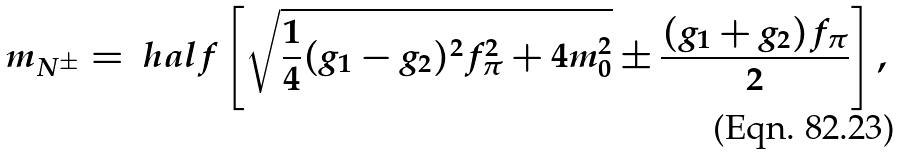Convert formula to latex. <formula><loc_0><loc_0><loc_500><loc_500>m _ { N ^ { \pm } } & = \ h a l f \left [ \sqrt { \frac { 1 } { 4 } ( g _ { 1 } - g _ { 2 } ) ^ { 2 } f _ { \pi } ^ { 2 } + 4 m _ { 0 } ^ { 2 } } \pm \frac { ( g _ { 1 } + g _ { 2 } ) f _ { \pi } } { 2 } \right ] ,</formula> 